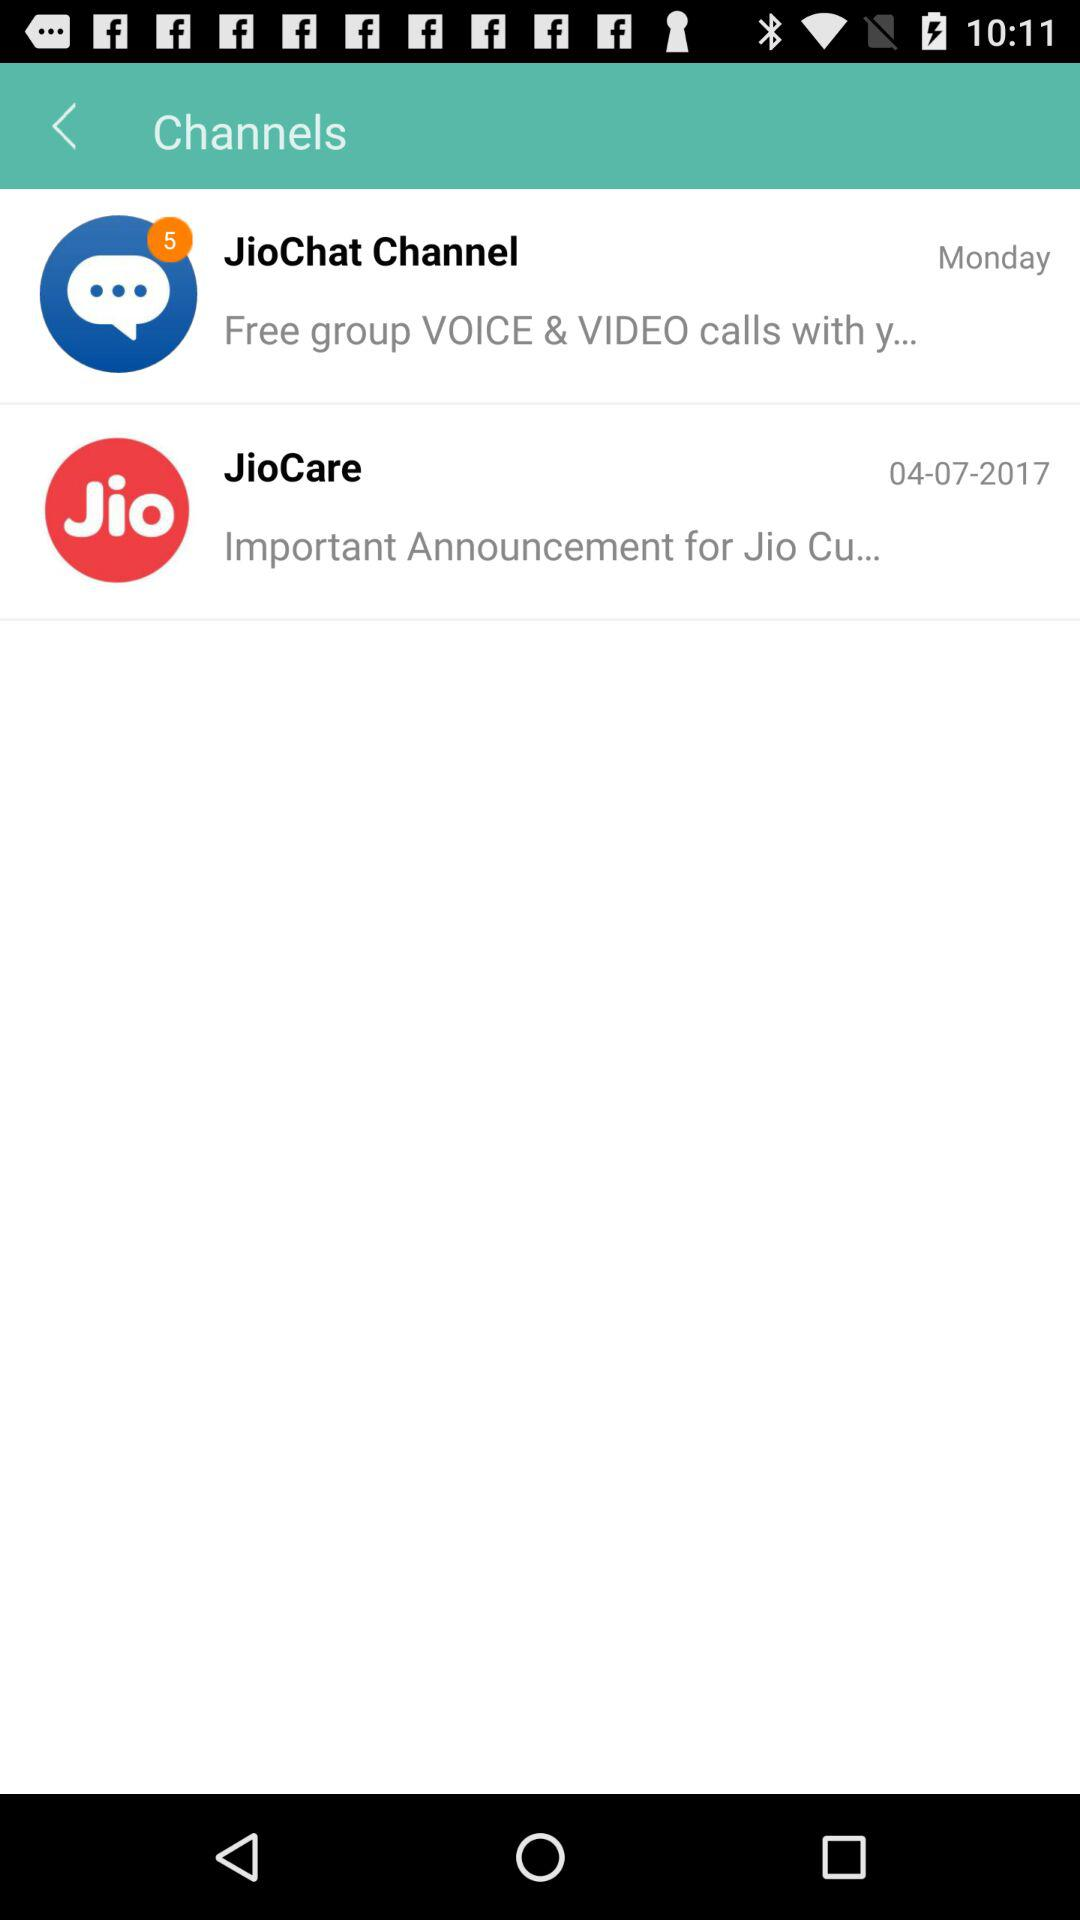What is the given date for "JioCare"? The given date for "JioCare" is April 7, 2017. 